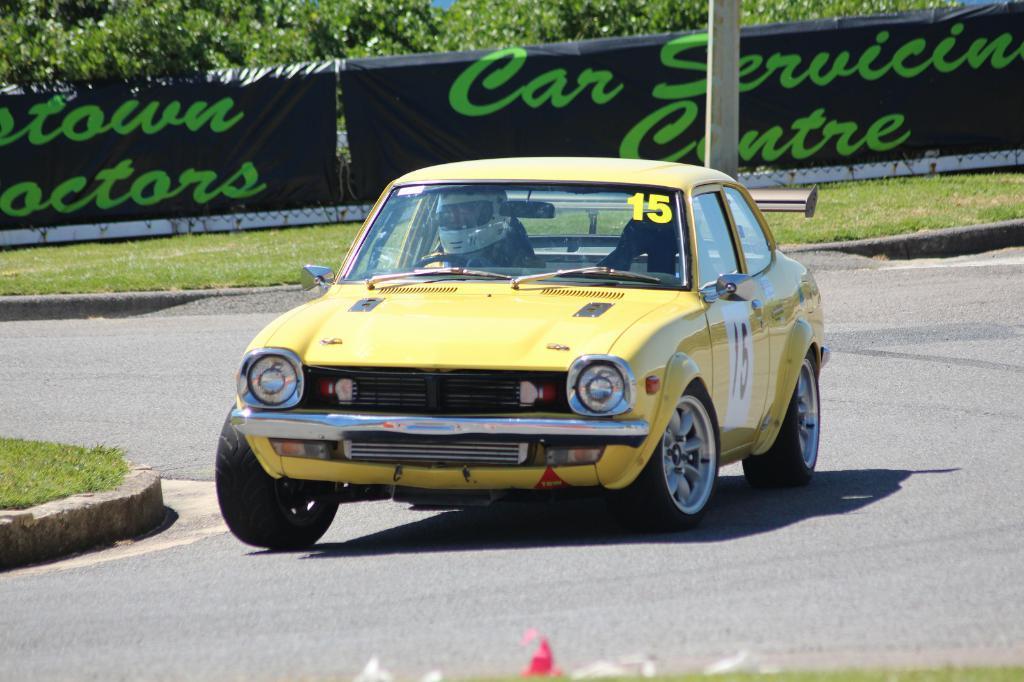In one or two sentences, can you explain what this image depicts? This is an outside view. Here I can see a yellow color car on the road. Inside the car there is a person wearing helmet to the head. On both sides of the road I can see the grass. In the background there is a banner on which I can see some text and also there is a pole. At the top of the image there are some trees. 